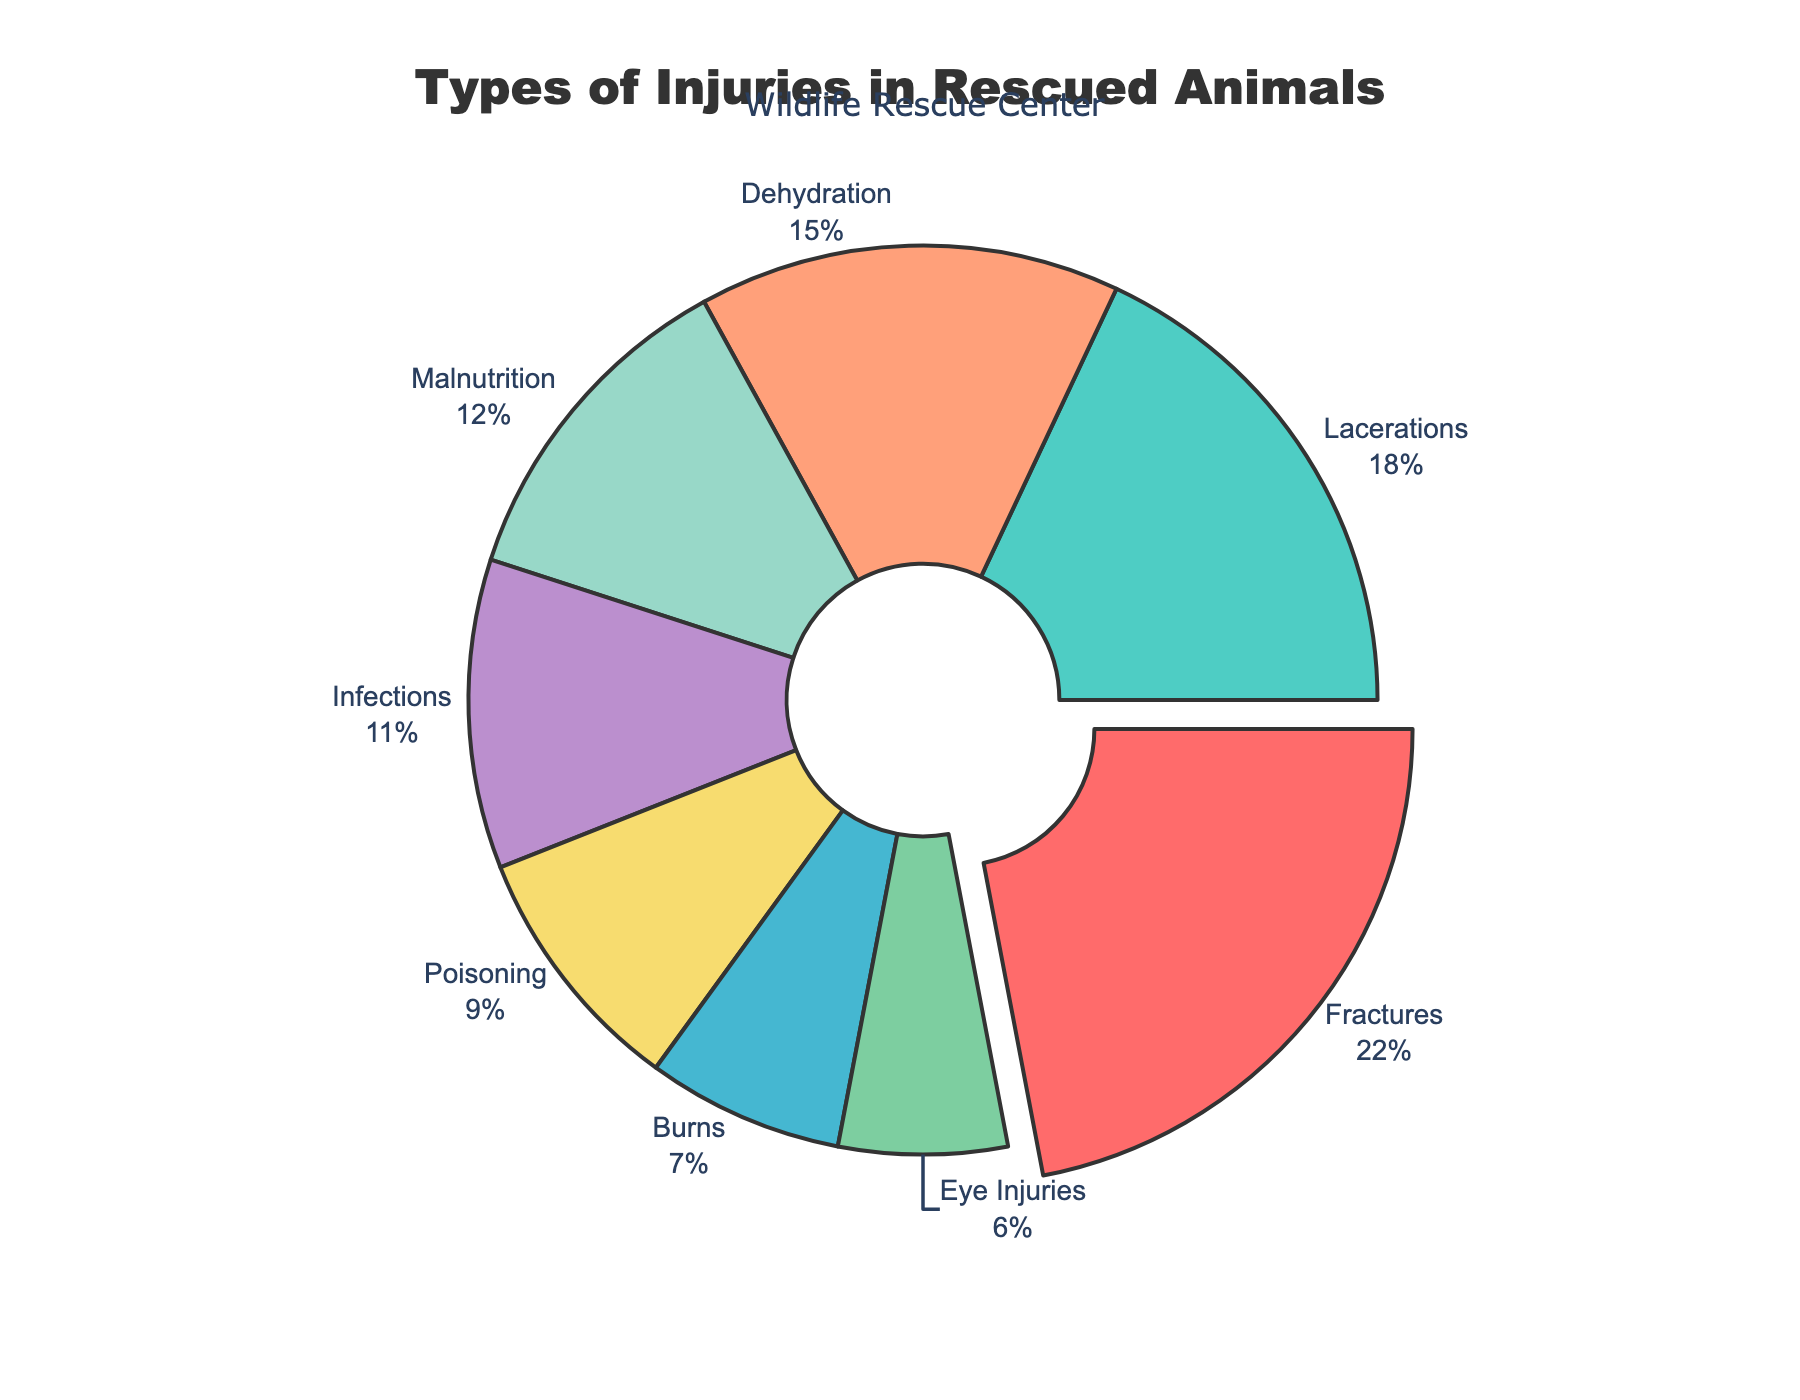What is the most common injury type in rescued animals? The most common injury type is identified by the largest percentage slice in the pie chart. The slice labeled "Fractures" takes up the largest portion of the pie, pulled out slightly, indicating it is the most common injury.
Answer: Fractures Which injury type has the smallest percentage? To determine the injury type with the smallest percentage, look for the smallest slice in the pie chart. The slice labeled "Eye Injuries" is the smallest.
Answer: Eye Injuries Which injury type percentages are greater than 10%? Look for the slices in the pie chart that represent more than 10% of the whole. The slices labeled "Fractures" (22%), "Lacerations" (18%), "Dehydration" (15%), and "Malnutrition" (12%) fit this criterion.
Answer: Fractures, Lacerations, Dehydration, Malnutrition How much more common are fractures compared to burns? Find the percentages for "Fractures" and "Burns" and compute the difference. Fractures are 22%, and Burns are 7%. The difference is 22 - 7 = 15%.
Answer: 15% What is the combined percentage of infections and poisoning? Add the percentages for "Infections" and "Poisoning". Infections are 11% and Poisoning is 9%. The sum is 11 + 9 = 20%.
Answer: 20% Are lacerations more common than malnutrition? By how much? Compare the percentages for "Lacerations" and "Malnutrition". Lacerations are 18%, and Malnutrition is 12%. The difference is 18 - 12 = 6%.
Answer: Yes, by 6% What percentage of injuries are either dehydration or malnutrition? Sum the percentages of "Dehydration" and "Malnutrition". Dehydration is 15% and Malnutrition is 12%. The total is 15 + 12 = 27%.
Answer: 27% What visual cue indicates which injury type is the most common? Identify the visual features of the pie chart. The slice representing the most common injury type, "Fractures", is slightly pulled out from the pie and is the largest.
Answer: Largest slice, pulled out Which injury types are represented by green and purple slices? Match the colors shown in the chart to the corresponding labels. The green slice represents "Lacerations" and the purple slice represents "Infections".
Answer: Lacerations (green), Infections (purple) Is the sum of fractures, lacerations, and burns greater than half of the total? Add the percentages of "Fractures" (22%), "Lacerations" (18%), and "Burns" (7%). The sum is 22 + 18 + 7 = 47%. Compare 47% to 50%.
Answer: No, 47% 